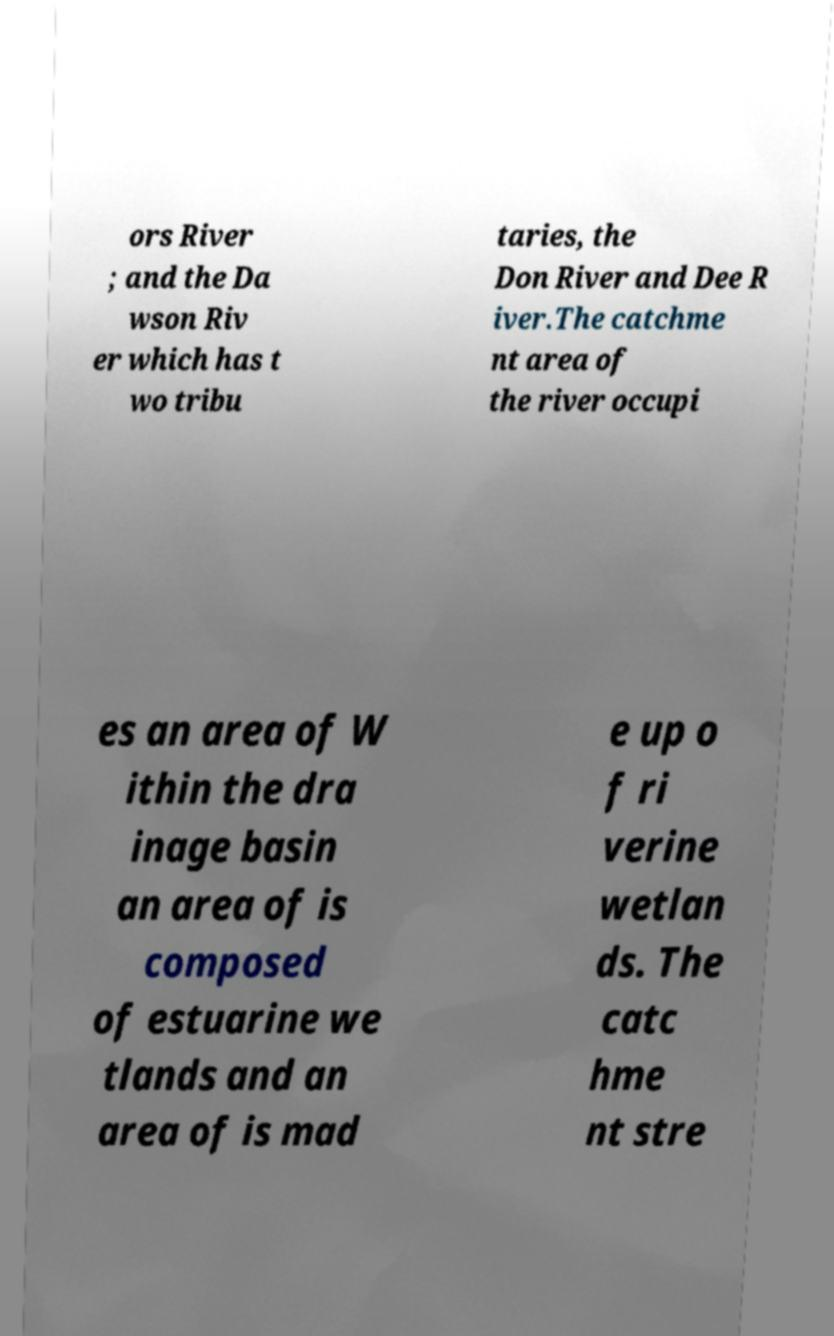There's text embedded in this image that I need extracted. Can you transcribe it verbatim? ors River ; and the Da wson Riv er which has t wo tribu taries, the Don River and Dee R iver.The catchme nt area of the river occupi es an area of W ithin the dra inage basin an area of is composed of estuarine we tlands and an area of is mad e up o f ri verine wetlan ds. The catc hme nt stre 